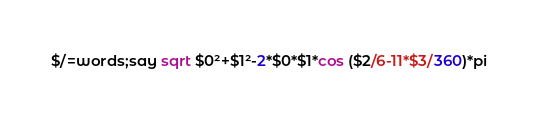Convert code to text. <code><loc_0><loc_0><loc_500><loc_500><_Perl_>$/=words;say sqrt $0²+$1²-2*$0*$1*cos ($2/6-11*$3/360)*pi</code> 